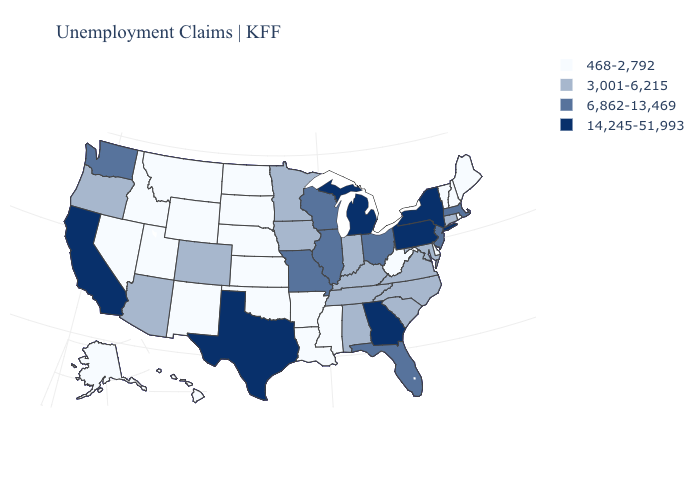What is the value of Virginia?
Answer briefly. 3,001-6,215. What is the value of Nevada?
Be succinct. 468-2,792. What is the highest value in the Northeast ?
Short answer required. 14,245-51,993. Does Louisiana have the lowest value in the USA?
Answer briefly. Yes. Name the states that have a value in the range 14,245-51,993?
Concise answer only. California, Georgia, Michigan, New York, Pennsylvania, Texas. What is the lowest value in the MidWest?
Concise answer only. 468-2,792. What is the lowest value in the USA?
Short answer required. 468-2,792. Does Idaho have the highest value in the West?
Keep it brief. No. What is the value of Nevada?
Give a very brief answer. 468-2,792. Does South Carolina have a lower value than California?
Answer briefly. Yes. Which states hav the highest value in the MidWest?
Concise answer only. Michigan. What is the lowest value in the USA?
Write a very short answer. 468-2,792. Is the legend a continuous bar?
Be succinct. No. Which states have the highest value in the USA?
Give a very brief answer. California, Georgia, Michigan, New York, Pennsylvania, Texas. What is the value of Indiana?
Keep it brief. 3,001-6,215. 